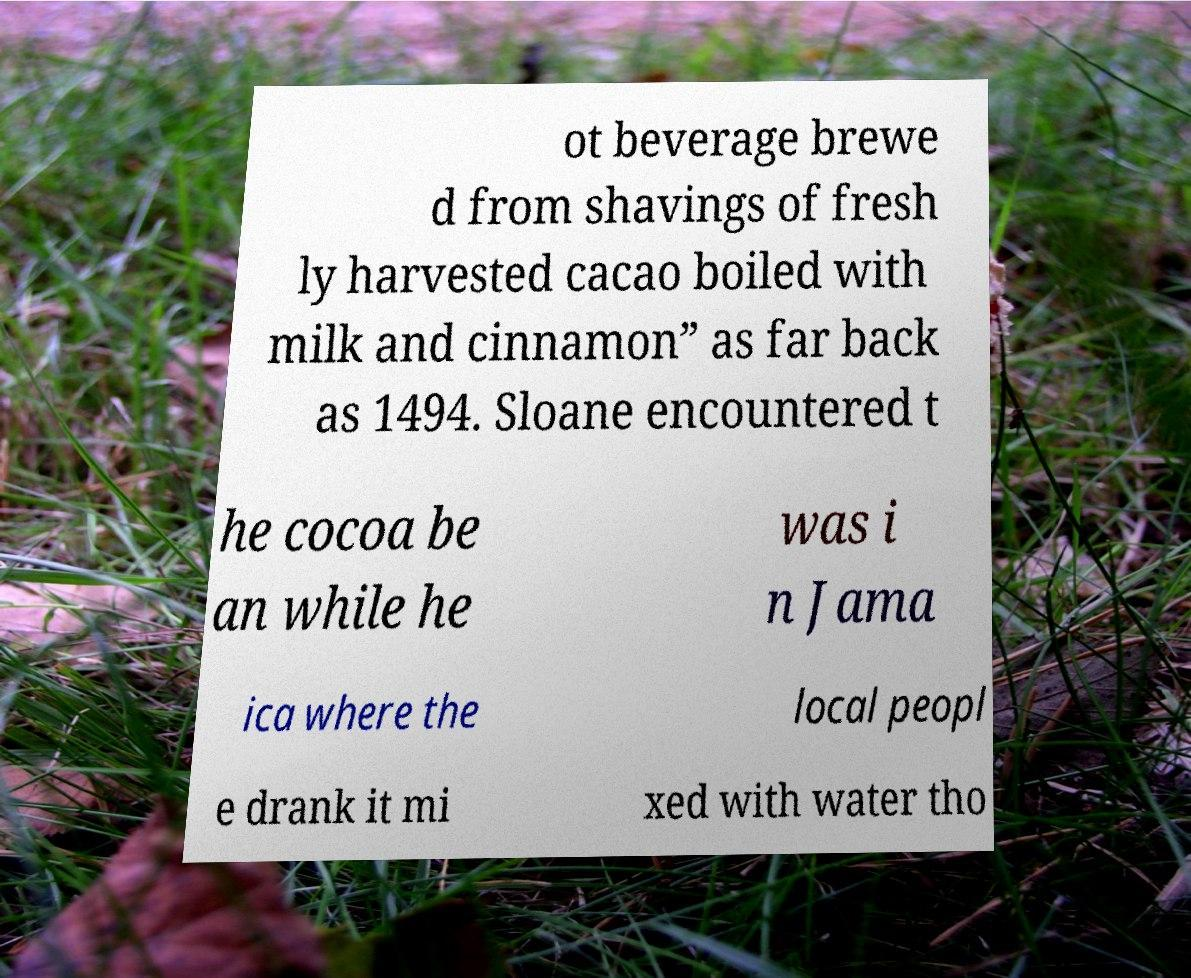For documentation purposes, I need the text within this image transcribed. Could you provide that? ot beverage brewe d from shavings of fresh ly harvested cacao boiled with milk and cinnamon” as far back as 1494. Sloane encountered t he cocoa be an while he was i n Jama ica where the local peopl e drank it mi xed with water tho 